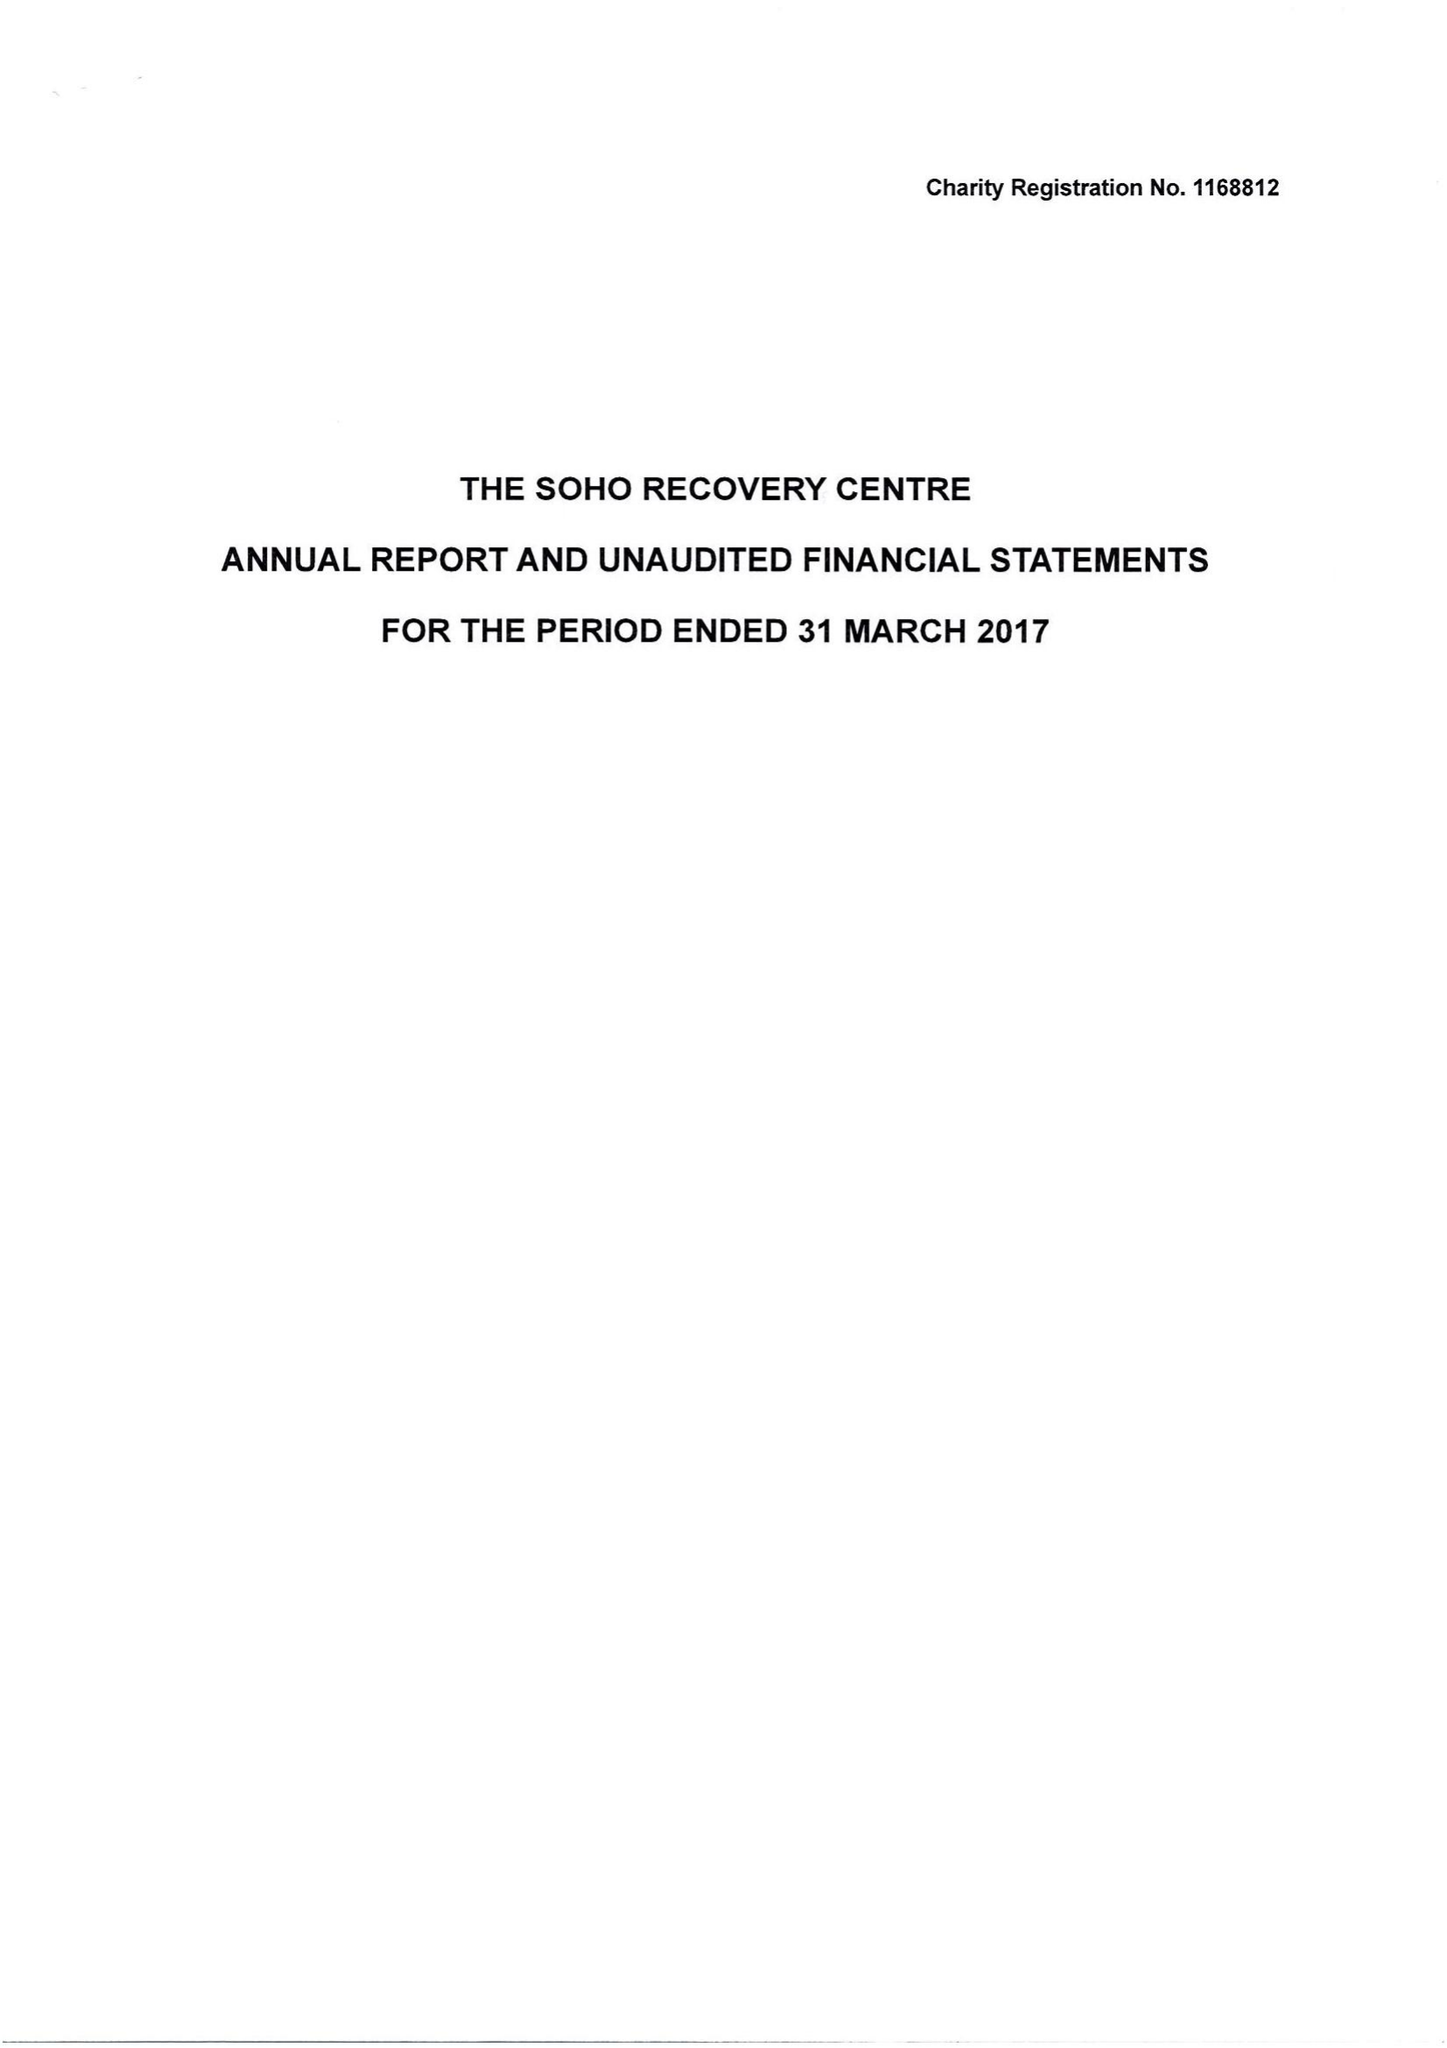What is the value for the report_date?
Answer the question using a single word or phrase. 2017-03-31 